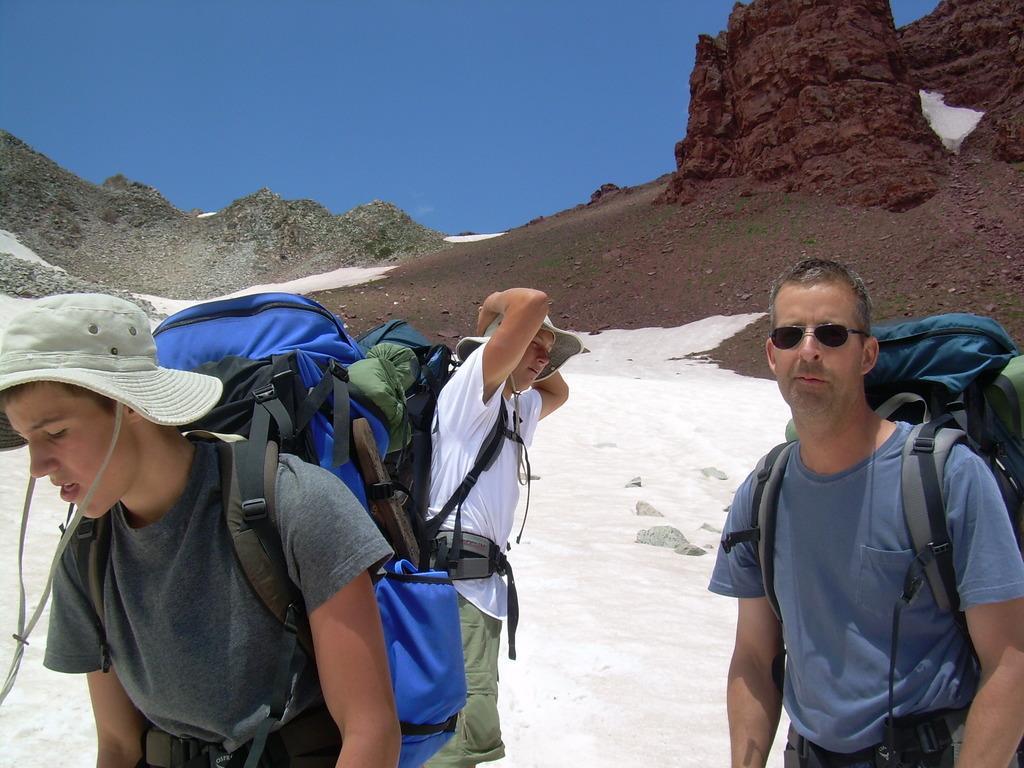Can you describe this image briefly? In this image there are group of persons wearing a backpacks , hats spectacle standing in a snow ,and in the back ground there are hills and sky. 